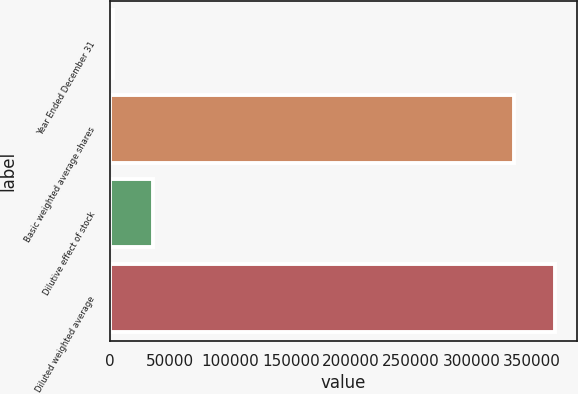Convert chart. <chart><loc_0><loc_0><loc_500><loc_500><bar_chart><fcel>Year Ended December 31<fcel>Basic weighted average shares<fcel>Dilutive effect of stock<fcel>Diluted weighted average<nl><fcel>2014<fcel>335192<fcel>35945.7<fcel>369124<nl></chart> 